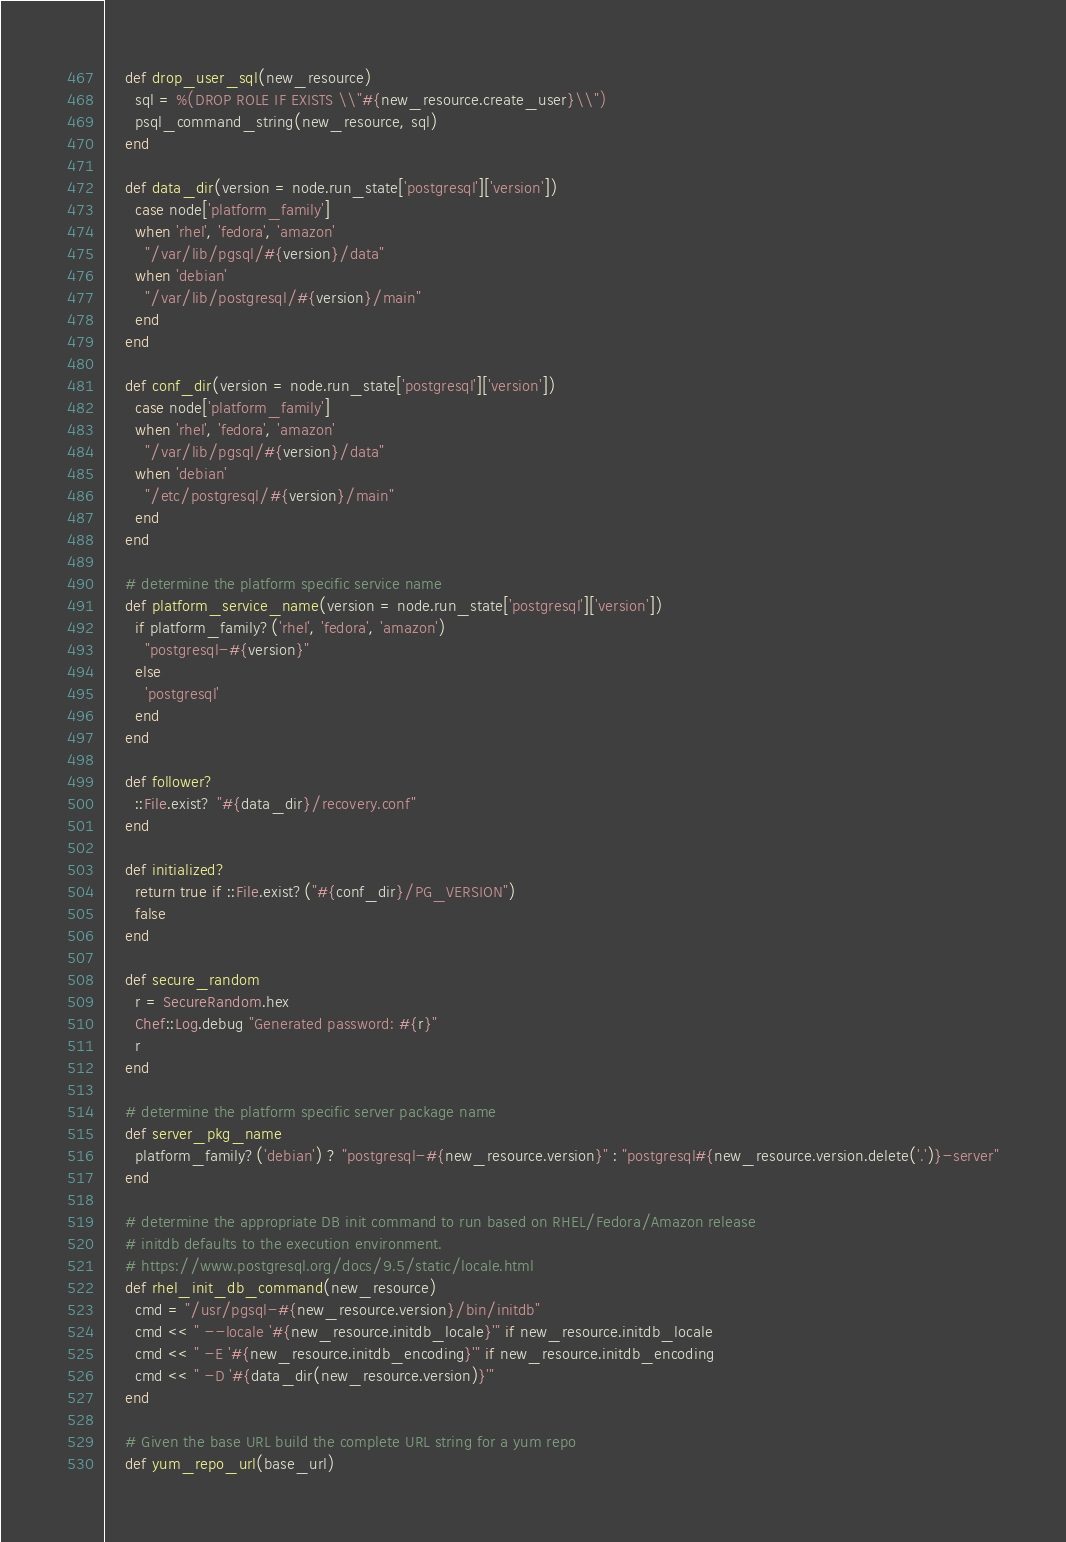<code> <loc_0><loc_0><loc_500><loc_500><_Ruby_>
    def drop_user_sql(new_resource)
      sql = %(DROP ROLE IF EXISTS \\"#{new_resource.create_user}\\")
      psql_command_string(new_resource, sql)
    end

    def data_dir(version = node.run_state['postgresql']['version'])
      case node['platform_family']
      when 'rhel', 'fedora', 'amazon'
        "/var/lib/pgsql/#{version}/data"
      when 'debian'
        "/var/lib/postgresql/#{version}/main"
      end
    end

    def conf_dir(version = node.run_state['postgresql']['version'])
      case node['platform_family']
      when 'rhel', 'fedora', 'amazon'
        "/var/lib/pgsql/#{version}/data"
      when 'debian'
        "/etc/postgresql/#{version}/main"
      end
    end

    # determine the platform specific service name
    def platform_service_name(version = node.run_state['postgresql']['version'])
      if platform_family?('rhel', 'fedora', 'amazon')
        "postgresql-#{version}"
      else
        'postgresql'
      end
    end

    def follower?
      ::File.exist? "#{data_dir}/recovery.conf"
    end

    def initialized?
      return true if ::File.exist?("#{conf_dir}/PG_VERSION")
      false
    end

    def secure_random
      r = SecureRandom.hex
      Chef::Log.debug "Generated password: #{r}"
      r
    end

    # determine the platform specific server package name
    def server_pkg_name
      platform_family?('debian') ? "postgresql-#{new_resource.version}" : "postgresql#{new_resource.version.delete('.')}-server"
    end

    # determine the appropriate DB init command to run based on RHEL/Fedora/Amazon release
    # initdb defaults to the execution environment.
    # https://www.postgresql.org/docs/9.5/static/locale.html
    def rhel_init_db_command(new_resource)
      cmd = "/usr/pgsql-#{new_resource.version}/bin/initdb"
      cmd << " --locale '#{new_resource.initdb_locale}'" if new_resource.initdb_locale
      cmd << " -E '#{new_resource.initdb_encoding}'" if new_resource.initdb_encoding
      cmd << " -D '#{data_dir(new_resource.version)}'"
    end

    # Given the base URL build the complete URL string for a yum repo
    def yum_repo_url(base_url)</code> 